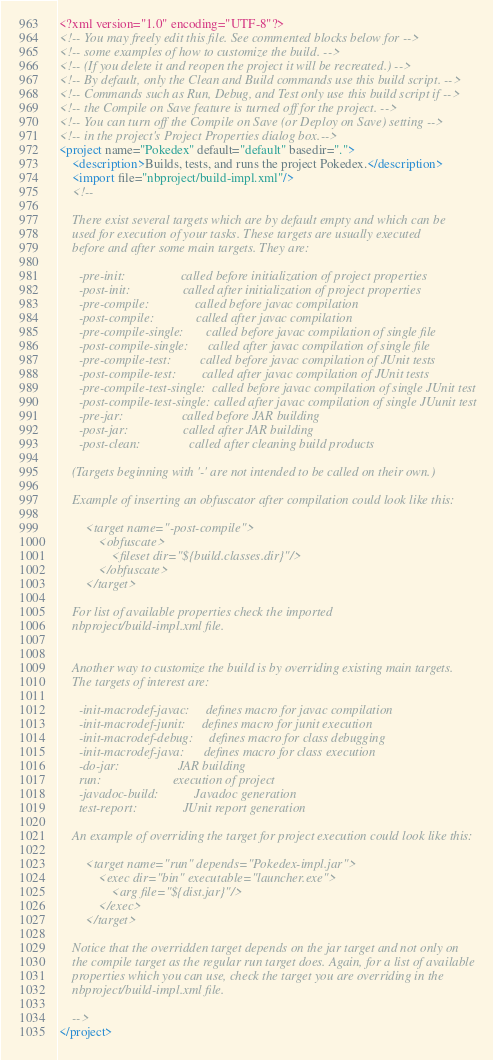<code> <loc_0><loc_0><loc_500><loc_500><_XML_><?xml version="1.0" encoding="UTF-8"?>
<!-- You may freely edit this file. See commented blocks below for -->
<!-- some examples of how to customize the build. -->
<!-- (If you delete it and reopen the project it will be recreated.) -->
<!-- By default, only the Clean and Build commands use this build script. -->
<!-- Commands such as Run, Debug, and Test only use this build script if -->
<!-- the Compile on Save feature is turned off for the project. -->
<!-- You can turn off the Compile on Save (or Deploy on Save) setting -->
<!-- in the project's Project Properties dialog box.-->
<project name="Pokedex" default="default" basedir=".">
    <description>Builds, tests, and runs the project Pokedex.</description>
    <import file="nbproject/build-impl.xml"/>
    <!--

    There exist several targets which are by default empty and which can be 
    used for execution of your tasks. These targets are usually executed 
    before and after some main targets. They are: 

      -pre-init:                 called before initialization of project properties
      -post-init:                called after initialization of project properties
      -pre-compile:              called before javac compilation
      -post-compile:             called after javac compilation
      -pre-compile-single:       called before javac compilation of single file
      -post-compile-single:      called after javac compilation of single file
      -pre-compile-test:         called before javac compilation of JUnit tests
      -post-compile-test:        called after javac compilation of JUnit tests
      -pre-compile-test-single:  called before javac compilation of single JUnit test
      -post-compile-test-single: called after javac compilation of single JUunit test
      -pre-jar:                  called before JAR building
      -post-jar:                 called after JAR building
      -post-clean:               called after cleaning build products

    (Targets beginning with '-' are not intended to be called on their own.)

    Example of inserting an obfuscator after compilation could look like this:

        <target name="-post-compile">
            <obfuscate>
                <fileset dir="${build.classes.dir}"/>
            </obfuscate>
        </target>

    For list of available properties check the imported 
    nbproject/build-impl.xml file. 


    Another way to customize the build is by overriding existing main targets.
    The targets of interest are: 

      -init-macrodef-javac:     defines macro for javac compilation
      -init-macrodef-junit:     defines macro for junit execution
      -init-macrodef-debug:     defines macro for class debugging
      -init-macrodef-java:      defines macro for class execution
      -do-jar:                  JAR building
      run:                      execution of project 
      -javadoc-build:           Javadoc generation
      test-report:              JUnit report generation

    An example of overriding the target for project execution could look like this:

        <target name="run" depends="Pokedex-impl.jar">
            <exec dir="bin" executable="launcher.exe">
                <arg file="${dist.jar}"/>
            </exec>
        </target>

    Notice that the overridden target depends on the jar target and not only on 
    the compile target as the regular run target does. Again, for a list of available 
    properties which you can use, check the target you are overriding in the
    nbproject/build-impl.xml file. 

    -->
</project>
</code> 